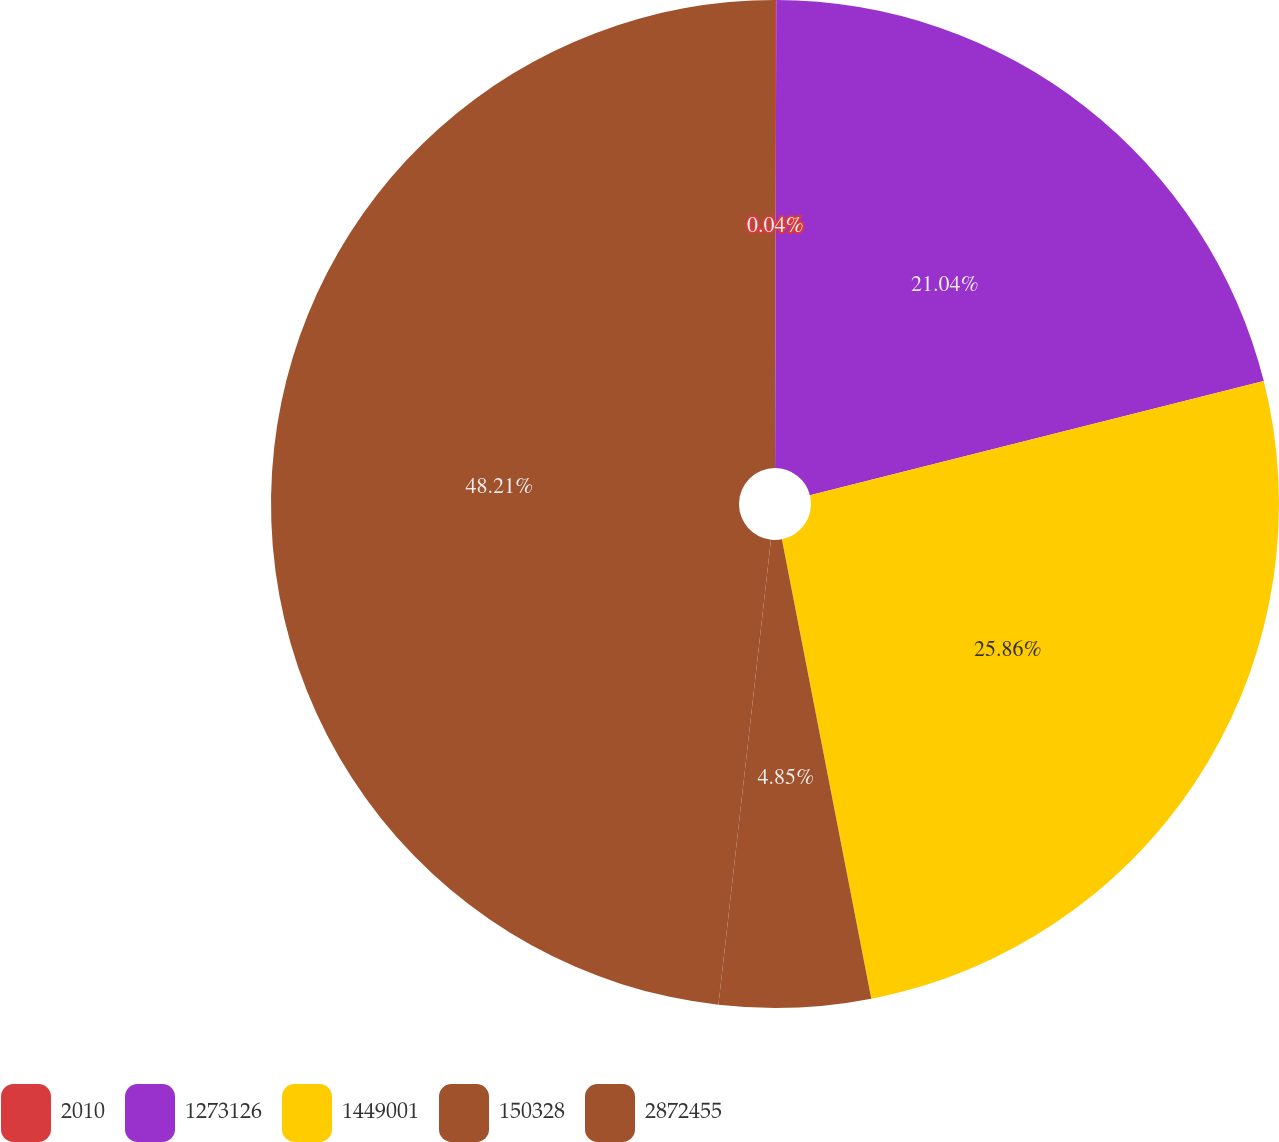Convert chart. <chart><loc_0><loc_0><loc_500><loc_500><pie_chart><fcel>2010<fcel>1273126<fcel>1449001<fcel>150328<fcel>2872455<nl><fcel>0.04%<fcel>21.04%<fcel>25.86%<fcel>4.85%<fcel>48.21%<nl></chart> 